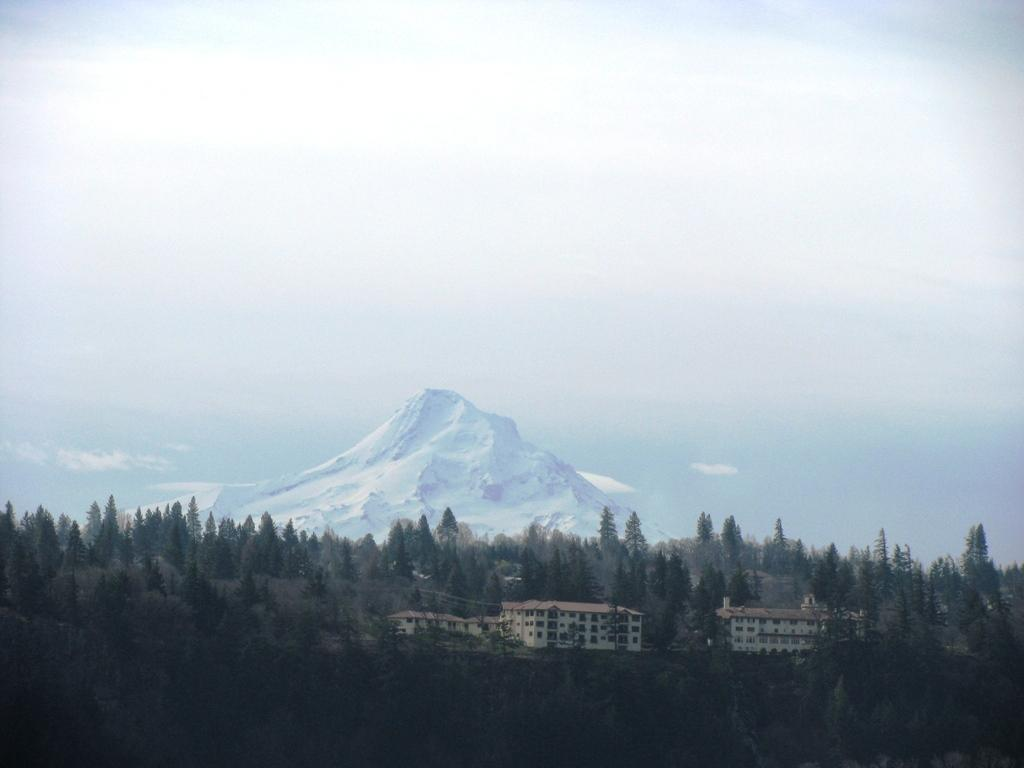What types of structures are located at the bottom of the image? There are trees and buildings at the bottom of the image. What natural feature can be seen in the background of the image? There is a snow mountain visible in the background of the image. What else is visible in the background of the image? The sky is visible in the background of the image. What type of game is being played by the carpenter in the image? There is no carpenter or game present in the image. How does the rest of the image relate to the carpenter's activities? The image does not depict any carpenter or their activities, so it is not possible to determine how the rest of the image relates to them. 